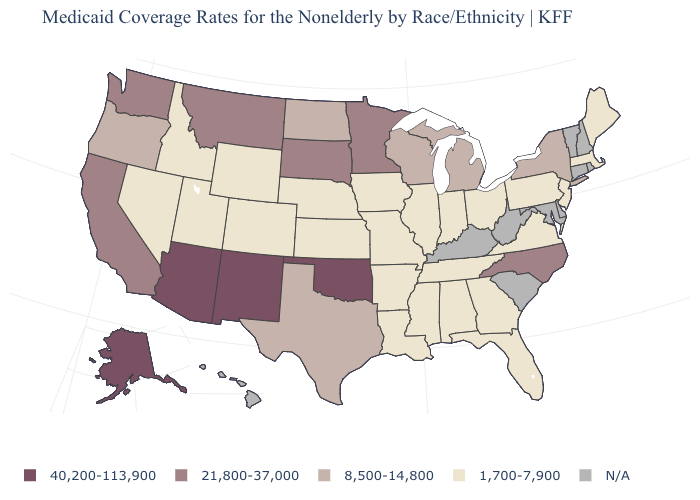Name the states that have a value in the range N/A?
Answer briefly. Connecticut, Delaware, Hawaii, Kentucky, Maryland, New Hampshire, Rhode Island, South Carolina, Vermont, West Virginia. What is the value of Oregon?
Answer briefly. 8,500-14,800. Does New York have the highest value in the Northeast?
Answer briefly. Yes. Name the states that have a value in the range 8,500-14,800?
Give a very brief answer. Michigan, New York, North Dakota, Oregon, Texas, Wisconsin. Name the states that have a value in the range 21,800-37,000?
Concise answer only. California, Minnesota, Montana, North Carolina, South Dakota, Washington. What is the value of Colorado?
Give a very brief answer. 1,700-7,900. Name the states that have a value in the range 1,700-7,900?
Be succinct. Alabama, Arkansas, Colorado, Florida, Georgia, Idaho, Illinois, Indiana, Iowa, Kansas, Louisiana, Maine, Massachusetts, Mississippi, Missouri, Nebraska, Nevada, New Jersey, Ohio, Pennsylvania, Tennessee, Utah, Virginia, Wyoming. Among the states that border Wyoming , which have the highest value?
Be succinct. Montana, South Dakota. Does Maine have the highest value in the Northeast?
Keep it brief. No. What is the lowest value in states that border Minnesota?
Keep it brief. 1,700-7,900. What is the value of South Carolina?
Quick response, please. N/A. Does the first symbol in the legend represent the smallest category?
Keep it brief. No. Name the states that have a value in the range 8,500-14,800?
Write a very short answer. Michigan, New York, North Dakota, Oregon, Texas, Wisconsin. Name the states that have a value in the range N/A?
Answer briefly. Connecticut, Delaware, Hawaii, Kentucky, Maryland, New Hampshire, Rhode Island, South Carolina, Vermont, West Virginia. What is the value of Kansas?
Quick response, please. 1,700-7,900. 